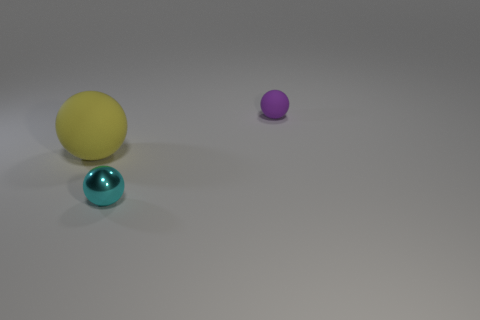There is a small purple object that is the same shape as the big object; what is its material?
Offer a terse response. Rubber. What number of things are matte objects left of the tiny purple ball or things that are to the right of the big rubber sphere?
Your answer should be very brief. 3. Does the small rubber sphere have the same color as the rubber object in front of the tiny rubber object?
Offer a very short reply. No. There is a big object that is the same material as the tiny purple sphere; what shape is it?
Your answer should be very brief. Sphere. What number of metal spheres are there?
Your answer should be very brief. 1. What number of objects are either matte things to the left of the small purple thing or shiny things?
Ensure brevity in your answer.  2. There is a rubber sphere on the left side of the purple rubber object; is its color the same as the tiny shiny object?
Offer a very short reply. No. How many other objects are there of the same color as the tiny matte object?
Your answer should be very brief. 0. How many large objects are either purple metallic balls or yellow objects?
Provide a succinct answer. 1. Is the number of tiny yellow rubber cubes greater than the number of yellow matte objects?
Offer a very short reply. No. 